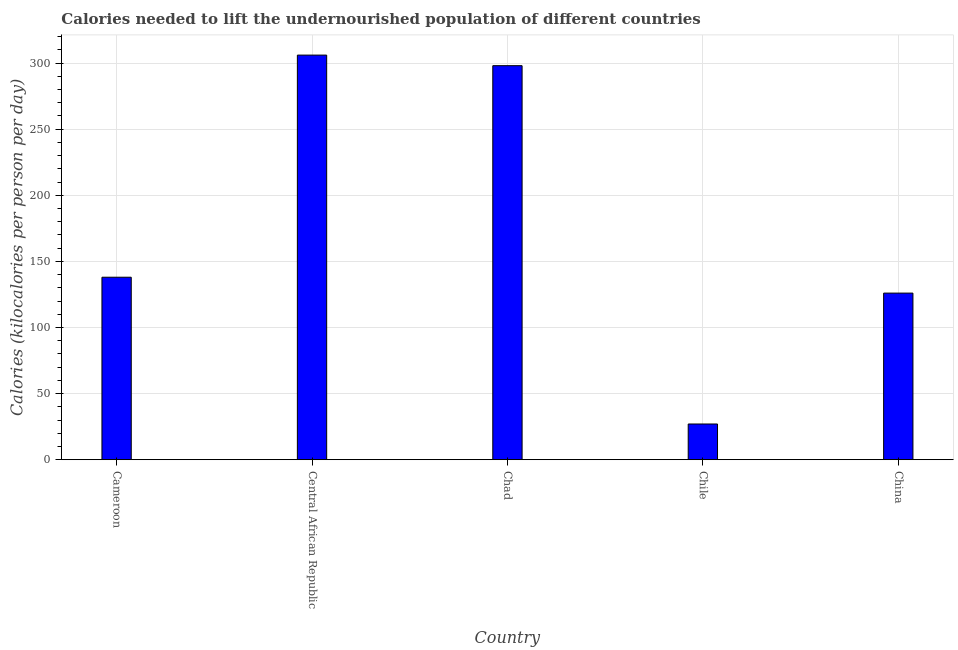Does the graph contain grids?
Provide a succinct answer. Yes. What is the title of the graph?
Your answer should be very brief. Calories needed to lift the undernourished population of different countries. What is the label or title of the Y-axis?
Offer a terse response. Calories (kilocalories per person per day). What is the depth of food deficit in China?
Provide a short and direct response. 126. Across all countries, what is the maximum depth of food deficit?
Your response must be concise. 306. In which country was the depth of food deficit maximum?
Provide a short and direct response. Central African Republic. In which country was the depth of food deficit minimum?
Make the answer very short. Chile. What is the sum of the depth of food deficit?
Keep it short and to the point. 895. What is the difference between the depth of food deficit in Cameroon and Chile?
Your answer should be compact. 111. What is the average depth of food deficit per country?
Keep it short and to the point. 179. What is the median depth of food deficit?
Offer a very short reply. 138. In how many countries, is the depth of food deficit greater than 120 kilocalories?
Your response must be concise. 4. What is the ratio of the depth of food deficit in Cameroon to that in Chad?
Your answer should be compact. 0.46. Is the depth of food deficit in Chile less than that in China?
Your answer should be compact. Yes. What is the difference between the highest and the lowest depth of food deficit?
Your response must be concise. 279. How many bars are there?
Provide a succinct answer. 5. Are all the bars in the graph horizontal?
Your answer should be very brief. No. What is the difference between two consecutive major ticks on the Y-axis?
Provide a short and direct response. 50. Are the values on the major ticks of Y-axis written in scientific E-notation?
Your response must be concise. No. What is the Calories (kilocalories per person per day) in Cameroon?
Offer a terse response. 138. What is the Calories (kilocalories per person per day) in Central African Republic?
Keep it short and to the point. 306. What is the Calories (kilocalories per person per day) of Chad?
Your answer should be very brief. 298. What is the Calories (kilocalories per person per day) in China?
Keep it short and to the point. 126. What is the difference between the Calories (kilocalories per person per day) in Cameroon and Central African Republic?
Provide a succinct answer. -168. What is the difference between the Calories (kilocalories per person per day) in Cameroon and Chad?
Your answer should be compact. -160. What is the difference between the Calories (kilocalories per person per day) in Cameroon and Chile?
Offer a very short reply. 111. What is the difference between the Calories (kilocalories per person per day) in Central African Republic and Chile?
Give a very brief answer. 279. What is the difference between the Calories (kilocalories per person per day) in Central African Republic and China?
Offer a very short reply. 180. What is the difference between the Calories (kilocalories per person per day) in Chad and Chile?
Ensure brevity in your answer.  271. What is the difference between the Calories (kilocalories per person per day) in Chad and China?
Offer a terse response. 172. What is the difference between the Calories (kilocalories per person per day) in Chile and China?
Offer a very short reply. -99. What is the ratio of the Calories (kilocalories per person per day) in Cameroon to that in Central African Republic?
Offer a terse response. 0.45. What is the ratio of the Calories (kilocalories per person per day) in Cameroon to that in Chad?
Your response must be concise. 0.46. What is the ratio of the Calories (kilocalories per person per day) in Cameroon to that in Chile?
Your answer should be compact. 5.11. What is the ratio of the Calories (kilocalories per person per day) in Cameroon to that in China?
Your answer should be very brief. 1.09. What is the ratio of the Calories (kilocalories per person per day) in Central African Republic to that in Chile?
Provide a short and direct response. 11.33. What is the ratio of the Calories (kilocalories per person per day) in Central African Republic to that in China?
Your answer should be compact. 2.43. What is the ratio of the Calories (kilocalories per person per day) in Chad to that in Chile?
Keep it short and to the point. 11.04. What is the ratio of the Calories (kilocalories per person per day) in Chad to that in China?
Offer a terse response. 2.37. What is the ratio of the Calories (kilocalories per person per day) in Chile to that in China?
Provide a succinct answer. 0.21. 